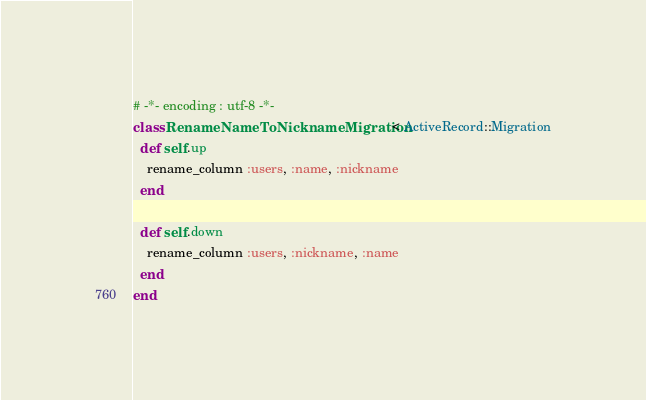<code> <loc_0><loc_0><loc_500><loc_500><_Ruby_># -*- encoding : utf-8 -*-
class RenameNameToNicknameMigration < ActiveRecord::Migration
  def self.up
    rename_column :users, :name, :nickname
  end

  def self.down
    rename_column :users, :nickname, :name
  end
end
</code> 